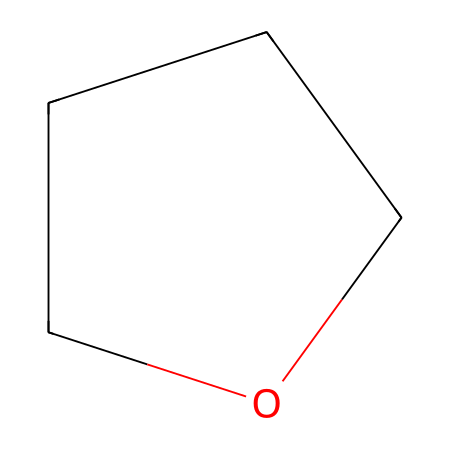What is the name of this chemical? The SMILES representation "C1CCCO1" denotes a six-membered ring structure with five carbons and one oxygen atom, which is specifically known as tetrahydrofuran.
Answer: tetrahydrofuran How many carbon atoms are in this chemical? By analyzing the SMILES "C1CCCO1", there are five 'C' characters which represent five carbon atoms in the structure.
Answer: five What type of chemical is tetrahydrofuran? Tetrahydrofuran is categorized as an ether due to its structure featuring an ether linkage (an oxygen atom between two carbon groups).
Answer: ether What is the total number of atoms in this molecule? The structure has five carbon atoms and one oxygen atom, contributing to a total atom count of six when combined.
Answer: six How many bonds are formed in this chemical? Each carbon atom in the ring formation bonds to adjacent carbon atoms and the oxygen, giving each carbon two bonds, leading to a total of five C-C bonds and one C-O bond, totaling six bonds.
Answer: six What is the significance of the ring structure in tetrahydrofuran? The ring structure allows tetrahydrofuran to be a solvent, as it can dissolve both polar and nonpolar substances due to its ability to interact through hydrogen bonding.
Answer: solvent 